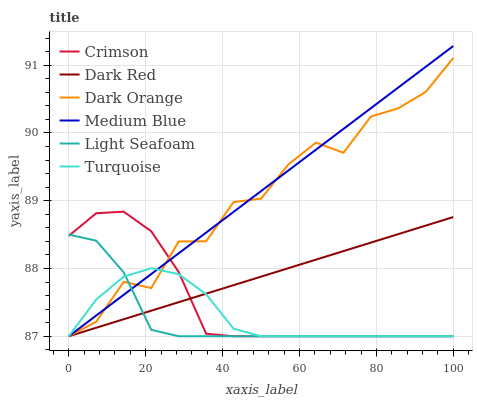Does Turquoise have the minimum area under the curve?
Answer yes or no. No. Does Turquoise have the maximum area under the curve?
Answer yes or no. No. Is Turquoise the smoothest?
Answer yes or no. No. Is Turquoise the roughest?
Answer yes or no. No. Does Dark Red have the highest value?
Answer yes or no. No. 